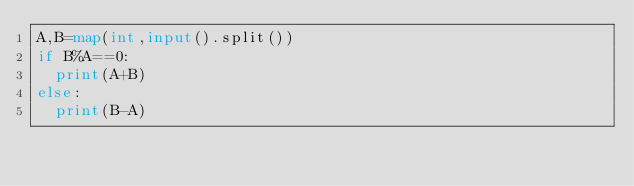<code> <loc_0><loc_0><loc_500><loc_500><_Python_>A,B=map(int,input().split())
if B%A==0:
  print(A+B)
else:
  print(B-A)</code> 